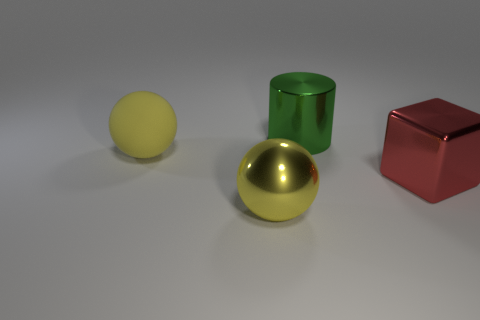Is the number of big things in front of the yellow rubber thing less than the number of large rubber balls that are on the left side of the red shiny object?
Make the answer very short. No. Are there any large things to the right of the cube?
Provide a succinct answer. No. How many objects are either yellow spheres behind the shiny sphere or yellow rubber objects behind the red metallic thing?
Ensure brevity in your answer.  1. How many matte objects have the same color as the large metal cylinder?
Your answer should be compact. 0. What color is the large metallic object that is the same shape as the big rubber thing?
Provide a short and direct response. Yellow. What is the shape of the big metal object that is both left of the red thing and behind the large yellow shiny object?
Keep it short and to the point. Cylinder. Is the number of big red blocks greater than the number of small red objects?
Your response must be concise. Yes. What is the large green thing made of?
Keep it short and to the point. Metal. Is there anything else that has the same size as the red object?
Offer a very short reply. Yes. The matte thing that is the same shape as the yellow metallic thing is what size?
Your answer should be very brief. Large. 